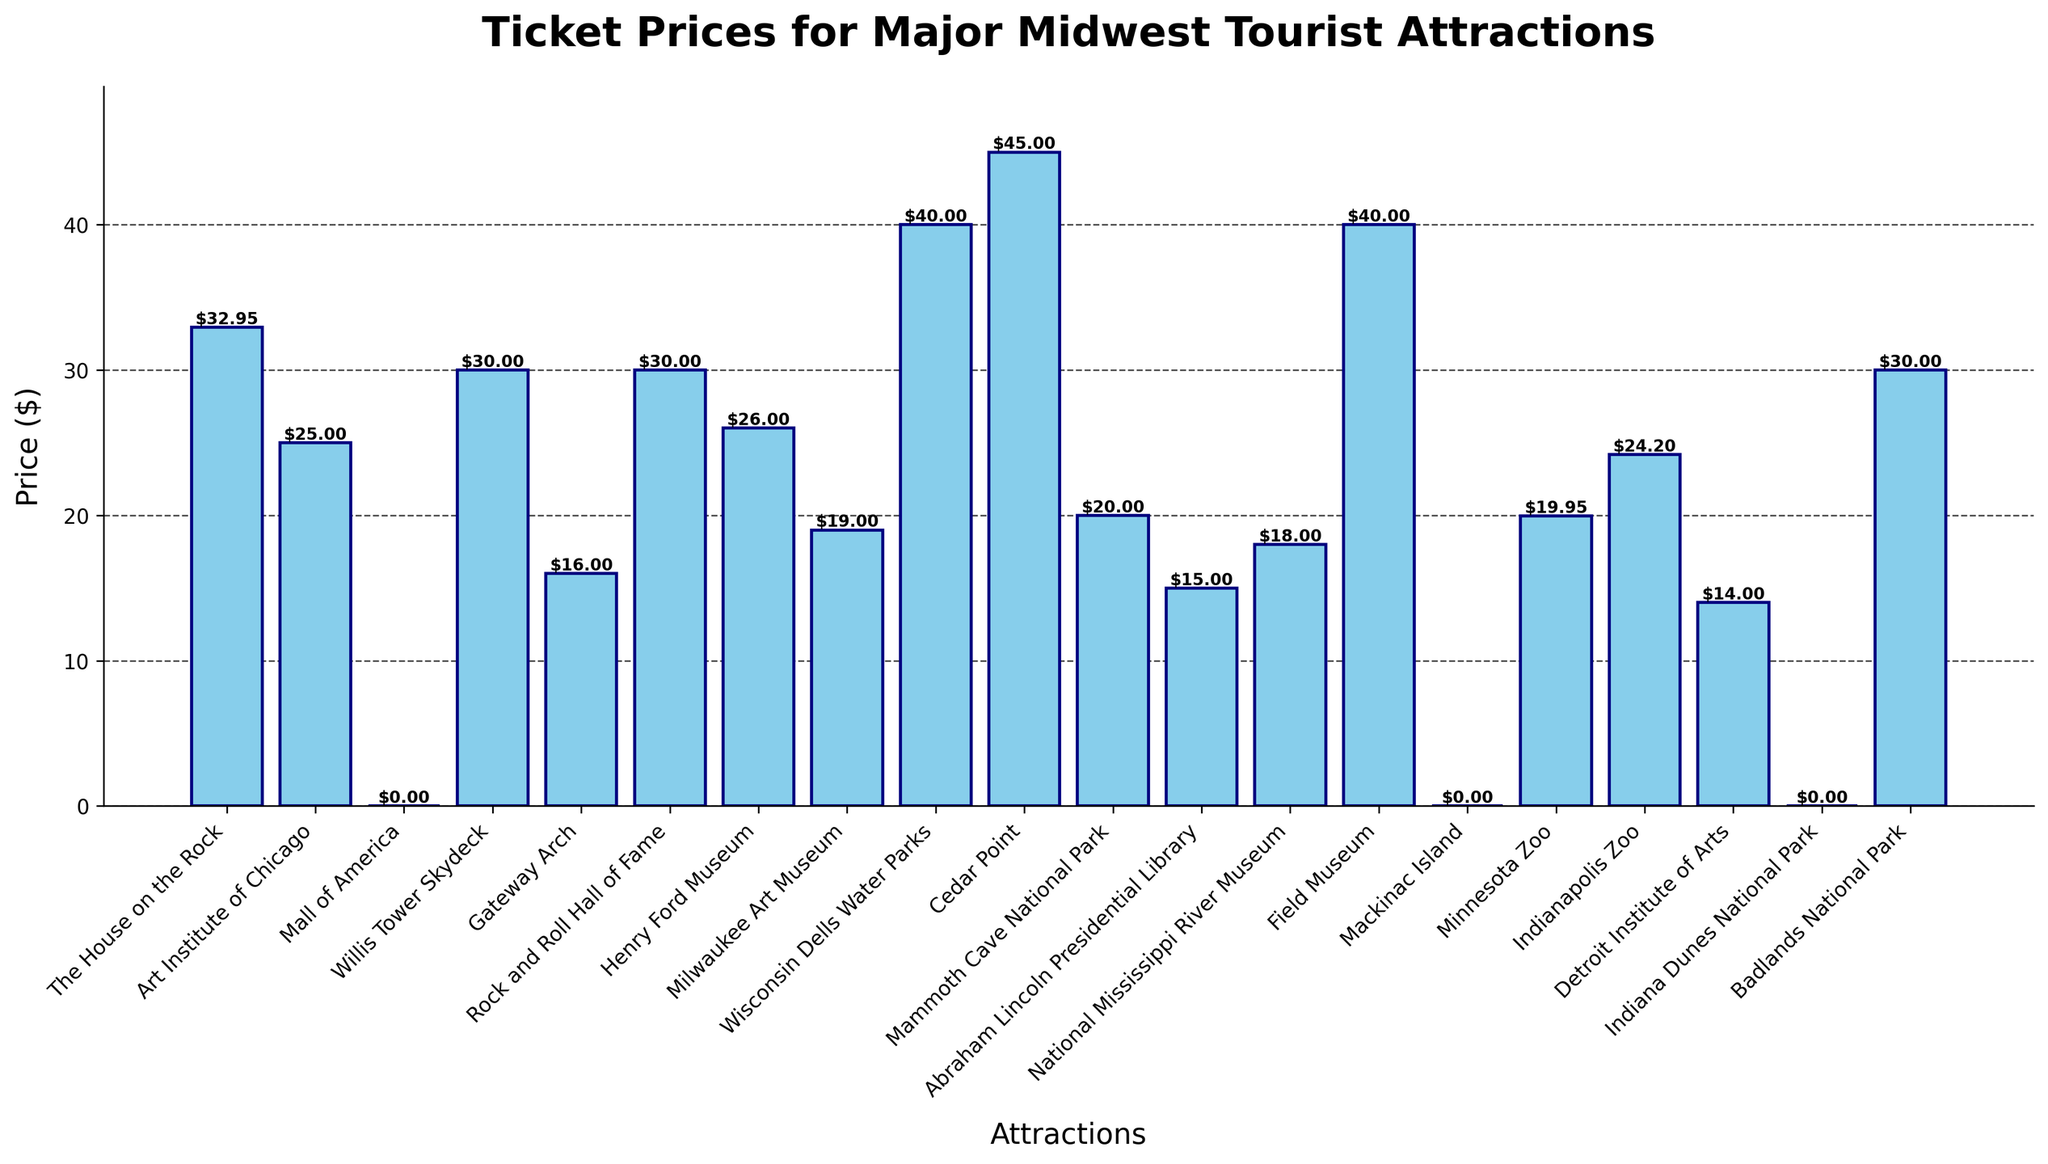Which tourist attraction has the highest ticket price? The bar corresponding to Cedar Point is the tallest, indicating it has the highest ticket price among the attractions listed in the chart.
Answer: Cedar Point Is the ticket price of "The House on the Rock" greater than the ticket price of the "Art Institute of Chicago"? The bar for "The House on the Rock" is taller than the bar for the "Art Institute of Chicago," indicating that the ticket price for "The House on the Rock" is higher.
Answer: Yes What is the difference in ticket price between the "Willis Tower Skydeck" and "Gateway Arch"? The bar for "Willis Tower Skydeck" has a height of 30 (dollars), and the bar for the "Gateway Arch" has a height of 16 (dollars). The difference is calculated as 30 - 16.
Answer: $14 Which attraction among "Milwaukee Art Museum," "Field Museum," and "Minnesota Zoo" has the lowest ticket price? Among the attractions listed, the "Milwaukee Art Museum" has the lowest bar height of $19, the "Field Museum" is $40, and the "Minnesota Zoo" is $19.95.
Answer: Milwaukee Art Museum How many attractions have a ticket price equal to or greater than $30? Counting the bars that reach or exceed the $30 mark includes "The House on the Rock," "Willis Tower Skydeck," "Rock and Roll Hall of Fame," "Field Museum," "Badlands National Park," and "Cedar Point." This totals six attractions.
Answer: 6 What is the average ticket price of "National Mississippi River Museum" and "Milwaukee Art Museum"? The ticket price for "National Mississippi River Museum" is $18, and for "Milwaukee Art Museum" is $19. The average is calculated as (18 + 19) / 2.
Answer: $18.50 Which attractions have free entry? The attractions with $0 ticket prices (shortest/zero-height bars) are the "Mall of America," "Mackinac Island," and "Indiana Dunes National Park."
Answer: Mall of America, Mackinac Island, Indiana Dunes National Park What is the combined ticket price of "Henry Ford Museum," "Abraham Lincoln Presidential Library," and "Detroit Institute of Arts"? The ticket prices are $26, $15, and $14 respectively. The combined price is 26 + 15 + 14.
Answer: $55 Which category has a larger ticket price, "Wisconsin Dells Water Parks" or "Field Museum"? The bars show that both "Wisconsin Dells Water Parks" and "Field Museum" are at $40, making their ticket prices equal.
Answer: Equal What is the visual difference between the tickets for "Mammoth Cave National Park" and "Minnesota Zoo"? The height of the bar for "Mammoth Cave National Park" is slightly less than that of "Minnesota Zoo" indicating that the ticket price of "Mammoth Cave National Park" is lower.
Answer: Mammoth Cave National Park is lower 